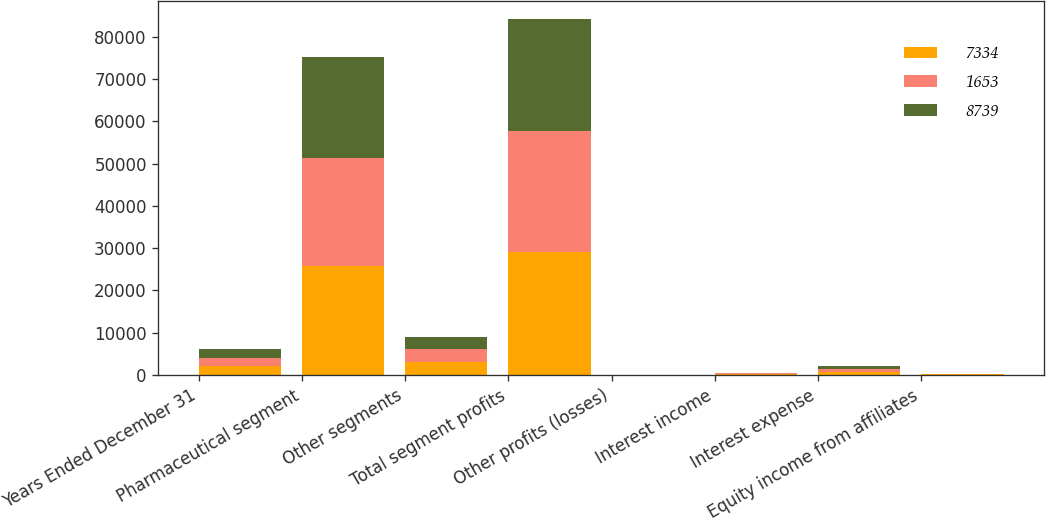Convert chart to OTSL. <chart><loc_0><loc_0><loc_500><loc_500><stacked_bar_chart><ecel><fcel>Years Ended December 31<fcel>Pharmaceutical segment<fcel>Other segments<fcel>Total segment profits<fcel>Other profits (losses)<fcel>Interest income<fcel>Interest expense<fcel>Equity income from affiliates<nl><fcel>7334<fcel>2012<fcel>25852<fcel>3163<fcel>29015<fcel>26<fcel>232<fcel>714<fcel>102<nl><fcel>1653<fcel>2011<fcel>25617<fcel>2995<fcel>28612<fcel>11<fcel>145<fcel>695<fcel>41<nl><fcel>8739<fcel>2010<fcel>23864<fcel>2849<fcel>26713<fcel>8<fcel>83<fcel>715<fcel>18<nl></chart> 